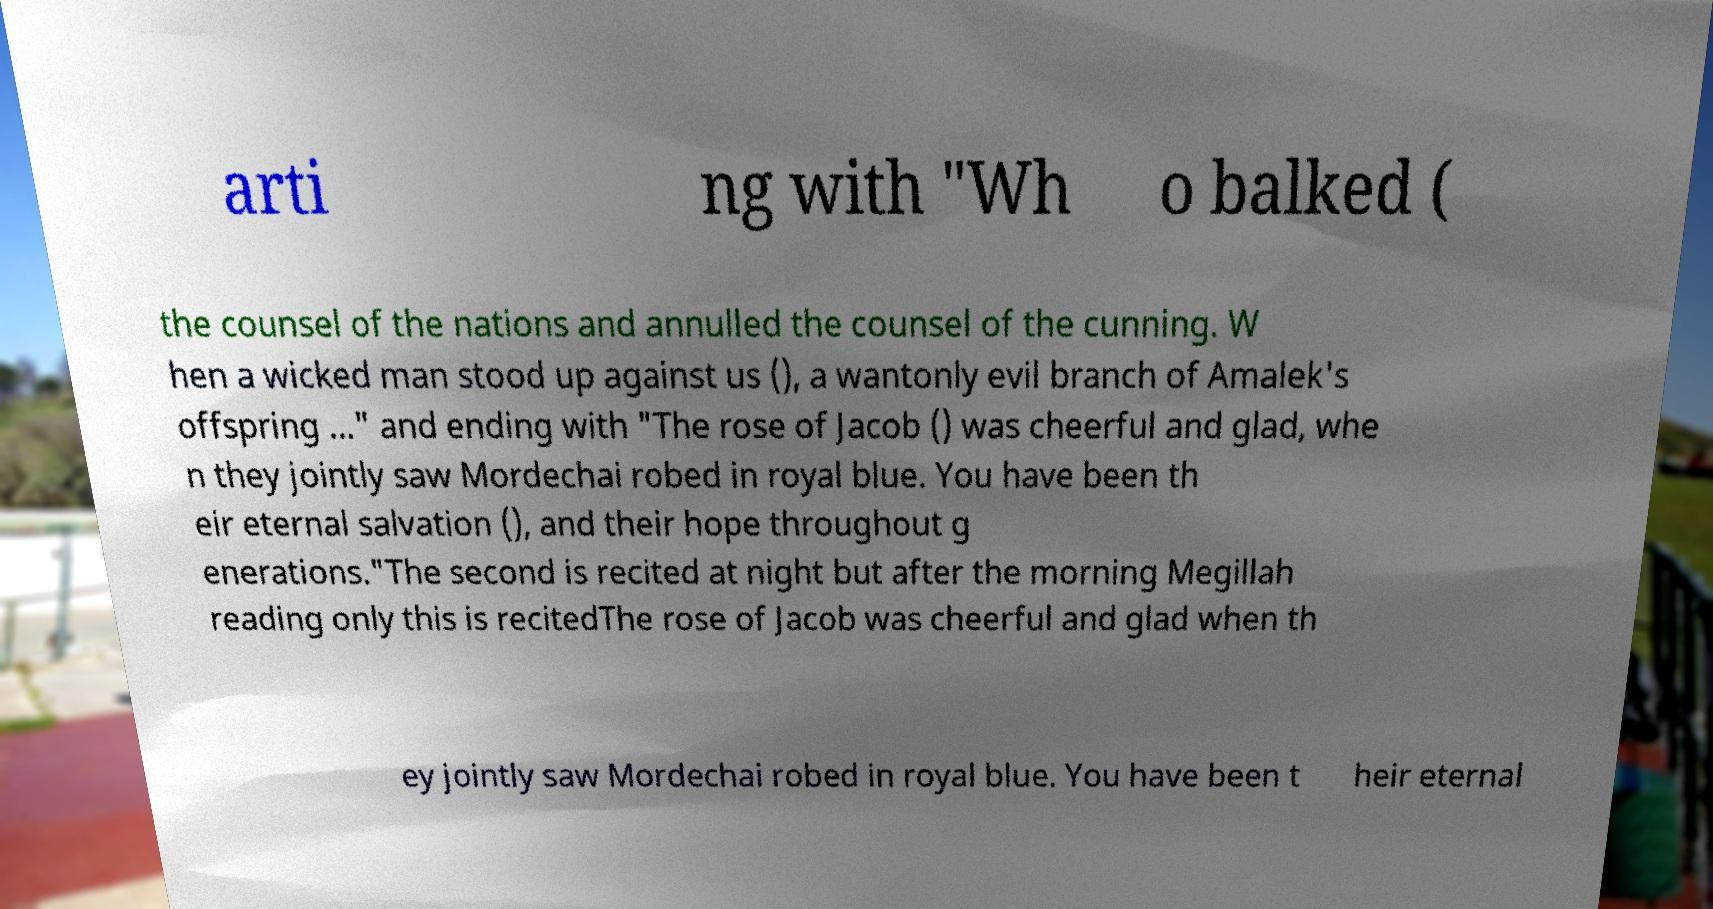Could you assist in decoding the text presented in this image and type it out clearly? arti ng with "Wh o balked ( the counsel of the nations and annulled the counsel of the cunning. W hen a wicked man stood up against us (), a wantonly evil branch of Amalek's offspring ..." and ending with "The rose of Jacob () was cheerful and glad, whe n they jointly saw Mordechai robed in royal blue. You have been th eir eternal salvation (), and their hope throughout g enerations."The second is recited at night but after the morning Megillah reading only this is recitedThe rose of Jacob was cheerful and glad when th ey jointly saw Mordechai robed in royal blue. You have been t heir eternal 